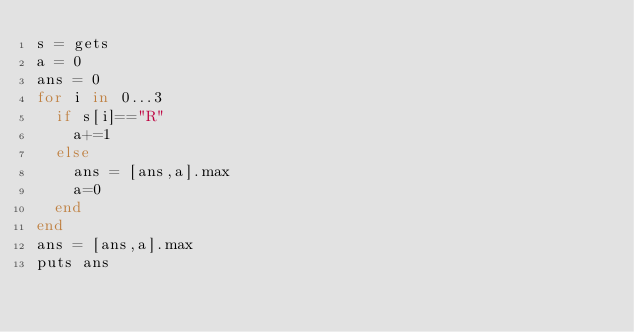Convert code to text. <code><loc_0><loc_0><loc_500><loc_500><_Ruby_>s = gets
a = 0
ans = 0
for i in 0...3
  if s[i]=="R"
    a+=1
  else
    ans = [ans,a].max
    a=0
  end
end
ans = [ans,a].max
puts ans</code> 